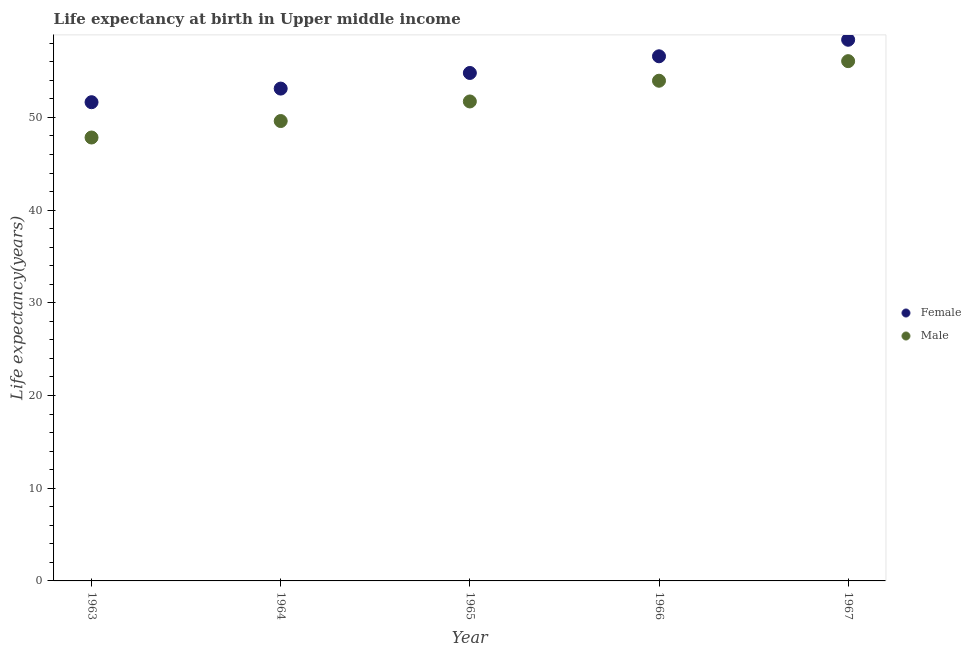What is the life expectancy(female) in 1964?
Provide a short and direct response. 53.11. Across all years, what is the maximum life expectancy(male)?
Your response must be concise. 56.07. Across all years, what is the minimum life expectancy(female)?
Make the answer very short. 51.65. In which year was the life expectancy(female) maximum?
Provide a short and direct response. 1967. What is the total life expectancy(female) in the graph?
Your answer should be very brief. 274.54. What is the difference between the life expectancy(male) in 1963 and that in 1965?
Offer a very short reply. -3.89. What is the difference between the life expectancy(male) in 1963 and the life expectancy(female) in 1966?
Your answer should be very brief. -8.76. What is the average life expectancy(female) per year?
Offer a terse response. 54.91. In the year 1965, what is the difference between the life expectancy(male) and life expectancy(female)?
Your answer should be very brief. -3.07. In how many years, is the life expectancy(female) greater than 56 years?
Offer a terse response. 2. What is the ratio of the life expectancy(male) in 1965 to that in 1966?
Make the answer very short. 0.96. Is the life expectancy(male) in 1963 less than that in 1967?
Provide a succinct answer. Yes. What is the difference between the highest and the second highest life expectancy(female)?
Your response must be concise. 1.78. What is the difference between the highest and the lowest life expectancy(female)?
Your answer should be very brief. 6.74. Is the sum of the life expectancy(female) in 1964 and 1965 greater than the maximum life expectancy(male) across all years?
Offer a terse response. Yes. Does the life expectancy(male) monotonically increase over the years?
Provide a short and direct response. Yes. Is the life expectancy(male) strictly greater than the life expectancy(female) over the years?
Offer a very short reply. No. Is the life expectancy(female) strictly less than the life expectancy(male) over the years?
Your response must be concise. No. How many dotlines are there?
Your answer should be compact. 2. Are the values on the major ticks of Y-axis written in scientific E-notation?
Ensure brevity in your answer.  No. Where does the legend appear in the graph?
Give a very brief answer. Center right. How many legend labels are there?
Provide a succinct answer. 2. How are the legend labels stacked?
Provide a short and direct response. Vertical. What is the title of the graph?
Your answer should be compact. Life expectancy at birth in Upper middle income. Does "Register a business" appear as one of the legend labels in the graph?
Your answer should be compact. No. What is the label or title of the X-axis?
Ensure brevity in your answer.  Year. What is the label or title of the Y-axis?
Keep it short and to the point. Life expectancy(years). What is the Life expectancy(years) of Female in 1963?
Keep it short and to the point. 51.65. What is the Life expectancy(years) in Male in 1963?
Your response must be concise. 47.84. What is the Life expectancy(years) in Female in 1964?
Ensure brevity in your answer.  53.11. What is the Life expectancy(years) of Male in 1964?
Provide a succinct answer. 49.61. What is the Life expectancy(years) in Female in 1965?
Provide a succinct answer. 54.8. What is the Life expectancy(years) in Male in 1965?
Make the answer very short. 51.73. What is the Life expectancy(years) in Female in 1966?
Make the answer very short. 56.6. What is the Life expectancy(years) of Male in 1966?
Give a very brief answer. 53.96. What is the Life expectancy(years) in Female in 1967?
Offer a terse response. 58.38. What is the Life expectancy(years) in Male in 1967?
Make the answer very short. 56.07. Across all years, what is the maximum Life expectancy(years) in Female?
Your answer should be compact. 58.38. Across all years, what is the maximum Life expectancy(years) of Male?
Your answer should be compact. 56.07. Across all years, what is the minimum Life expectancy(years) of Female?
Provide a short and direct response. 51.65. Across all years, what is the minimum Life expectancy(years) in Male?
Ensure brevity in your answer.  47.84. What is the total Life expectancy(years) in Female in the graph?
Make the answer very short. 274.54. What is the total Life expectancy(years) of Male in the graph?
Your response must be concise. 259.21. What is the difference between the Life expectancy(years) of Female in 1963 and that in 1964?
Provide a succinct answer. -1.47. What is the difference between the Life expectancy(years) of Male in 1963 and that in 1964?
Make the answer very short. -1.78. What is the difference between the Life expectancy(years) in Female in 1963 and that in 1965?
Offer a very short reply. -3.15. What is the difference between the Life expectancy(years) in Male in 1963 and that in 1965?
Provide a succinct answer. -3.89. What is the difference between the Life expectancy(years) in Female in 1963 and that in 1966?
Give a very brief answer. -4.95. What is the difference between the Life expectancy(years) of Male in 1963 and that in 1966?
Offer a very short reply. -6.13. What is the difference between the Life expectancy(years) of Female in 1963 and that in 1967?
Give a very brief answer. -6.74. What is the difference between the Life expectancy(years) in Male in 1963 and that in 1967?
Offer a very short reply. -8.24. What is the difference between the Life expectancy(years) in Female in 1964 and that in 1965?
Your answer should be compact. -1.69. What is the difference between the Life expectancy(years) in Male in 1964 and that in 1965?
Make the answer very short. -2.11. What is the difference between the Life expectancy(years) of Female in 1964 and that in 1966?
Your answer should be very brief. -3.48. What is the difference between the Life expectancy(years) of Male in 1964 and that in 1966?
Provide a succinct answer. -4.35. What is the difference between the Life expectancy(years) in Female in 1964 and that in 1967?
Your response must be concise. -5.27. What is the difference between the Life expectancy(years) in Male in 1964 and that in 1967?
Your answer should be very brief. -6.46. What is the difference between the Life expectancy(years) of Female in 1965 and that in 1966?
Your response must be concise. -1.8. What is the difference between the Life expectancy(years) in Male in 1965 and that in 1966?
Keep it short and to the point. -2.24. What is the difference between the Life expectancy(years) in Female in 1965 and that in 1967?
Your response must be concise. -3.58. What is the difference between the Life expectancy(years) in Male in 1965 and that in 1967?
Provide a succinct answer. -4.35. What is the difference between the Life expectancy(years) of Female in 1966 and that in 1967?
Offer a very short reply. -1.78. What is the difference between the Life expectancy(years) of Male in 1966 and that in 1967?
Your answer should be very brief. -2.11. What is the difference between the Life expectancy(years) in Female in 1963 and the Life expectancy(years) in Male in 1964?
Ensure brevity in your answer.  2.03. What is the difference between the Life expectancy(years) of Female in 1963 and the Life expectancy(years) of Male in 1965?
Give a very brief answer. -0.08. What is the difference between the Life expectancy(years) in Female in 1963 and the Life expectancy(years) in Male in 1966?
Make the answer very short. -2.32. What is the difference between the Life expectancy(years) of Female in 1963 and the Life expectancy(years) of Male in 1967?
Your answer should be compact. -4.43. What is the difference between the Life expectancy(years) in Female in 1964 and the Life expectancy(years) in Male in 1965?
Keep it short and to the point. 1.39. What is the difference between the Life expectancy(years) of Female in 1964 and the Life expectancy(years) of Male in 1966?
Give a very brief answer. -0.85. What is the difference between the Life expectancy(years) of Female in 1964 and the Life expectancy(years) of Male in 1967?
Your answer should be compact. -2.96. What is the difference between the Life expectancy(years) of Female in 1965 and the Life expectancy(years) of Male in 1966?
Offer a very short reply. 0.84. What is the difference between the Life expectancy(years) of Female in 1965 and the Life expectancy(years) of Male in 1967?
Your answer should be very brief. -1.27. What is the difference between the Life expectancy(years) of Female in 1966 and the Life expectancy(years) of Male in 1967?
Offer a terse response. 0.52. What is the average Life expectancy(years) in Female per year?
Give a very brief answer. 54.91. What is the average Life expectancy(years) of Male per year?
Provide a succinct answer. 51.84. In the year 1963, what is the difference between the Life expectancy(years) in Female and Life expectancy(years) in Male?
Your answer should be compact. 3.81. In the year 1964, what is the difference between the Life expectancy(years) in Female and Life expectancy(years) in Male?
Keep it short and to the point. 3.5. In the year 1965, what is the difference between the Life expectancy(years) in Female and Life expectancy(years) in Male?
Your answer should be very brief. 3.07. In the year 1966, what is the difference between the Life expectancy(years) in Female and Life expectancy(years) in Male?
Provide a short and direct response. 2.64. In the year 1967, what is the difference between the Life expectancy(years) of Female and Life expectancy(years) of Male?
Your answer should be very brief. 2.31. What is the ratio of the Life expectancy(years) in Female in 1963 to that in 1964?
Provide a short and direct response. 0.97. What is the ratio of the Life expectancy(years) of Male in 1963 to that in 1964?
Keep it short and to the point. 0.96. What is the ratio of the Life expectancy(years) of Female in 1963 to that in 1965?
Provide a short and direct response. 0.94. What is the ratio of the Life expectancy(years) in Male in 1963 to that in 1965?
Ensure brevity in your answer.  0.92. What is the ratio of the Life expectancy(years) in Female in 1963 to that in 1966?
Offer a very short reply. 0.91. What is the ratio of the Life expectancy(years) in Male in 1963 to that in 1966?
Provide a short and direct response. 0.89. What is the ratio of the Life expectancy(years) in Female in 1963 to that in 1967?
Keep it short and to the point. 0.88. What is the ratio of the Life expectancy(years) in Male in 1963 to that in 1967?
Your answer should be compact. 0.85. What is the ratio of the Life expectancy(years) of Female in 1964 to that in 1965?
Give a very brief answer. 0.97. What is the ratio of the Life expectancy(years) of Male in 1964 to that in 1965?
Give a very brief answer. 0.96. What is the ratio of the Life expectancy(years) in Female in 1964 to that in 1966?
Provide a short and direct response. 0.94. What is the ratio of the Life expectancy(years) of Male in 1964 to that in 1966?
Offer a very short reply. 0.92. What is the ratio of the Life expectancy(years) of Female in 1964 to that in 1967?
Provide a succinct answer. 0.91. What is the ratio of the Life expectancy(years) in Male in 1964 to that in 1967?
Offer a very short reply. 0.88. What is the ratio of the Life expectancy(years) in Female in 1965 to that in 1966?
Make the answer very short. 0.97. What is the ratio of the Life expectancy(years) in Male in 1965 to that in 1966?
Provide a succinct answer. 0.96. What is the ratio of the Life expectancy(years) in Female in 1965 to that in 1967?
Offer a very short reply. 0.94. What is the ratio of the Life expectancy(years) in Male in 1965 to that in 1967?
Provide a succinct answer. 0.92. What is the ratio of the Life expectancy(years) of Female in 1966 to that in 1967?
Your answer should be very brief. 0.97. What is the ratio of the Life expectancy(years) in Male in 1966 to that in 1967?
Give a very brief answer. 0.96. What is the difference between the highest and the second highest Life expectancy(years) of Female?
Your answer should be very brief. 1.78. What is the difference between the highest and the second highest Life expectancy(years) of Male?
Offer a terse response. 2.11. What is the difference between the highest and the lowest Life expectancy(years) in Female?
Provide a succinct answer. 6.74. What is the difference between the highest and the lowest Life expectancy(years) of Male?
Offer a terse response. 8.24. 